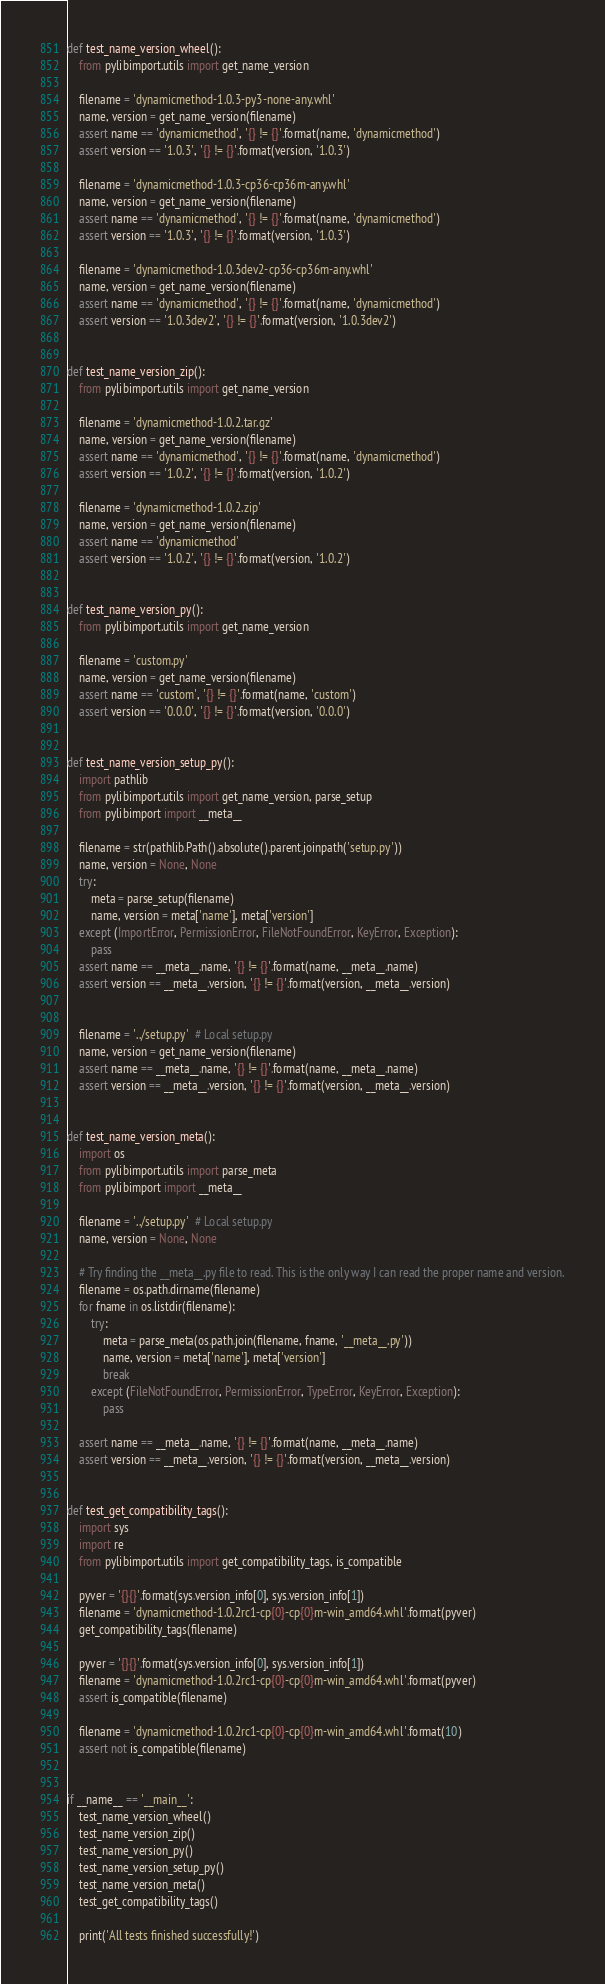Convert code to text. <code><loc_0><loc_0><loc_500><loc_500><_Python_>

def test_name_version_wheel():
    from pylibimport.utils import get_name_version

    filename = 'dynamicmethod-1.0.3-py3-none-any.whl'
    name, version = get_name_version(filename)
    assert name == 'dynamicmethod', '{} != {}'.format(name, 'dynamicmethod')
    assert version == '1.0.3', '{} != {}'.format(version, '1.0.3')

    filename = 'dynamicmethod-1.0.3-cp36-cp36m-any.whl'
    name, version = get_name_version(filename)
    assert name == 'dynamicmethod', '{} != {}'.format(name, 'dynamicmethod')
    assert version == '1.0.3', '{} != {}'.format(version, '1.0.3')

    filename = 'dynamicmethod-1.0.3dev2-cp36-cp36m-any.whl'
    name, version = get_name_version(filename)
    assert name == 'dynamicmethod', '{} != {}'.format(name, 'dynamicmethod')
    assert version == '1.0.3dev2', '{} != {}'.format(version, '1.0.3dev2')


def test_name_version_zip():
    from pylibimport.utils import get_name_version

    filename = 'dynamicmethod-1.0.2.tar.gz'
    name, version = get_name_version(filename)
    assert name == 'dynamicmethod', '{} != {}'.format(name, 'dynamicmethod')
    assert version == '1.0.2', '{} != {}'.format(version, '1.0.2')

    filename = 'dynamicmethod-1.0.2.zip'
    name, version = get_name_version(filename)
    assert name == 'dynamicmethod'
    assert version == '1.0.2', '{} != {}'.format(version, '1.0.2')


def test_name_version_py():
    from pylibimport.utils import get_name_version

    filename = 'custom.py'
    name, version = get_name_version(filename)
    assert name == 'custom', '{} != {}'.format(name, 'custom')
    assert version == '0.0.0', '{} != {}'.format(version, '0.0.0')


def test_name_version_setup_py():
    import pathlib
    from pylibimport.utils import get_name_version, parse_setup
    from pylibimport import __meta__

    filename = str(pathlib.Path().absolute().parent.joinpath('setup.py'))
    name, version = None, None
    try:
        meta = parse_setup(filename)
        name, version = meta['name'], meta['version']
    except (ImportError, PermissionError, FileNotFoundError, KeyError, Exception):
        pass
    assert name == __meta__.name, '{} != {}'.format(name, __meta__.name)
    assert version == __meta__.version, '{} != {}'.format(version, __meta__.version)


    filename = '../setup.py'  # Local setup.py
    name, version = get_name_version(filename)
    assert name == __meta__.name, '{} != {}'.format(name, __meta__.name)
    assert version == __meta__.version, '{} != {}'.format(version, __meta__.version)


def test_name_version_meta():
    import os
    from pylibimport.utils import parse_meta
    from pylibimport import __meta__

    filename = '../setup.py'  # Local setup.py
    name, version = None, None

    # Try finding the __meta__.py file to read. This is the only way I can read the proper name and version.
    filename = os.path.dirname(filename)
    for fname in os.listdir(filename):
        try:
            meta = parse_meta(os.path.join(filename, fname, '__meta__.py'))
            name, version = meta['name'], meta['version']
            break
        except (FileNotFoundError, PermissionError, TypeError, KeyError, Exception):
            pass

    assert name == __meta__.name, '{} != {}'.format(name, __meta__.name)
    assert version == __meta__.version, '{} != {}'.format(version, __meta__.version)


def test_get_compatibility_tags():
    import sys
    import re
    from pylibimport.utils import get_compatibility_tags, is_compatible

    pyver = '{}{}'.format(sys.version_info[0], sys.version_info[1])
    filename = 'dynamicmethod-1.0.2rc1-cp{0}-cp{0}m-win_amd64.whl'.format(pyver)
    get_compatibility_tags(filename)

    pyver = '{}{}'.format(sys.version_info[0], sys.version_info[1])
    filename = 'dynamicmethod-1.0.2rc1-cp{0}-cp{0}m-win_amd64.whl'.format(pyver)
    assert is_compatible(filename)

    filename = 'dynamicmethod-1.0.2rc1-cp{0}-cp{0}m-win_amd64.whl'.format(10)
    assert not is_compatible(filename)


if __name__ == '__main__':
    test_name_version_wheel()
    test_name_version_zip()
    test_name_version_py()
    test_name_version_setup_py()
    test_name_version_meta()
    test_get_compatibility_tags()

    print('All tests finished successfully!')
</code> 